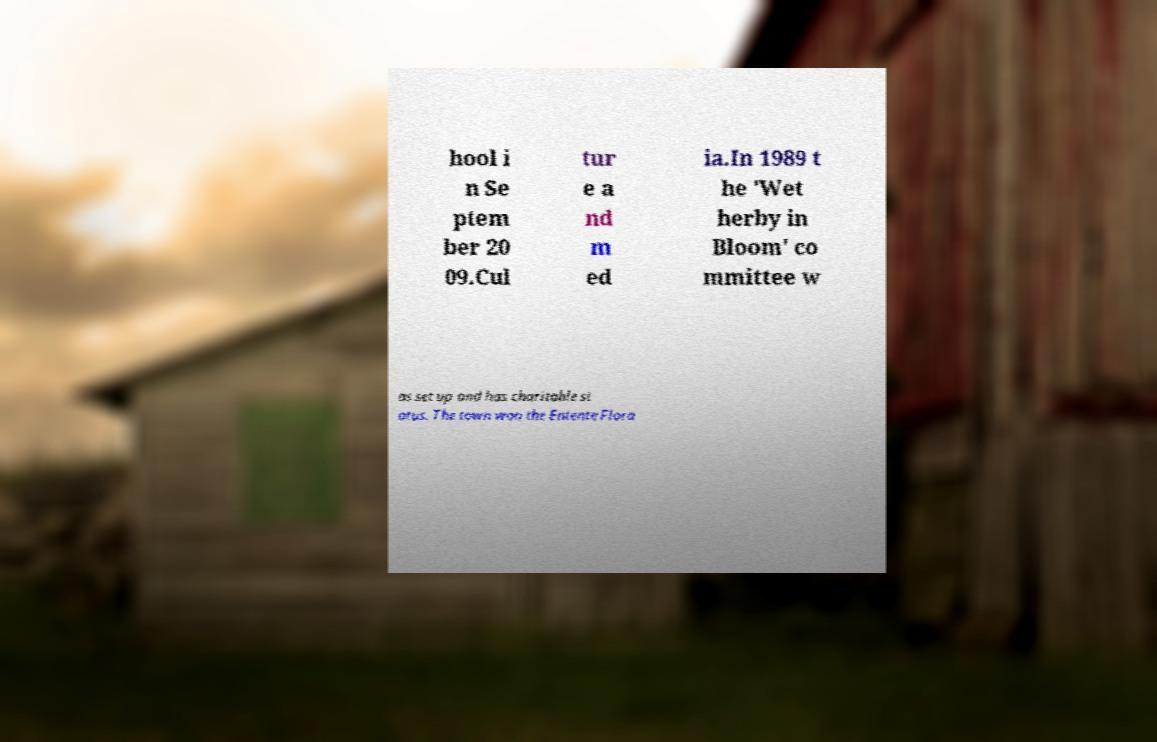Could you assist in decoding the text presented in this image and type it out clearly? hool i n Se ptem ber 20 09.Cul tur e a nd m ed ia.In 1989 t he 'Wet herby in Bloom' co mmittee w as set up and has charitable st atus. The town won the Entente Flora 